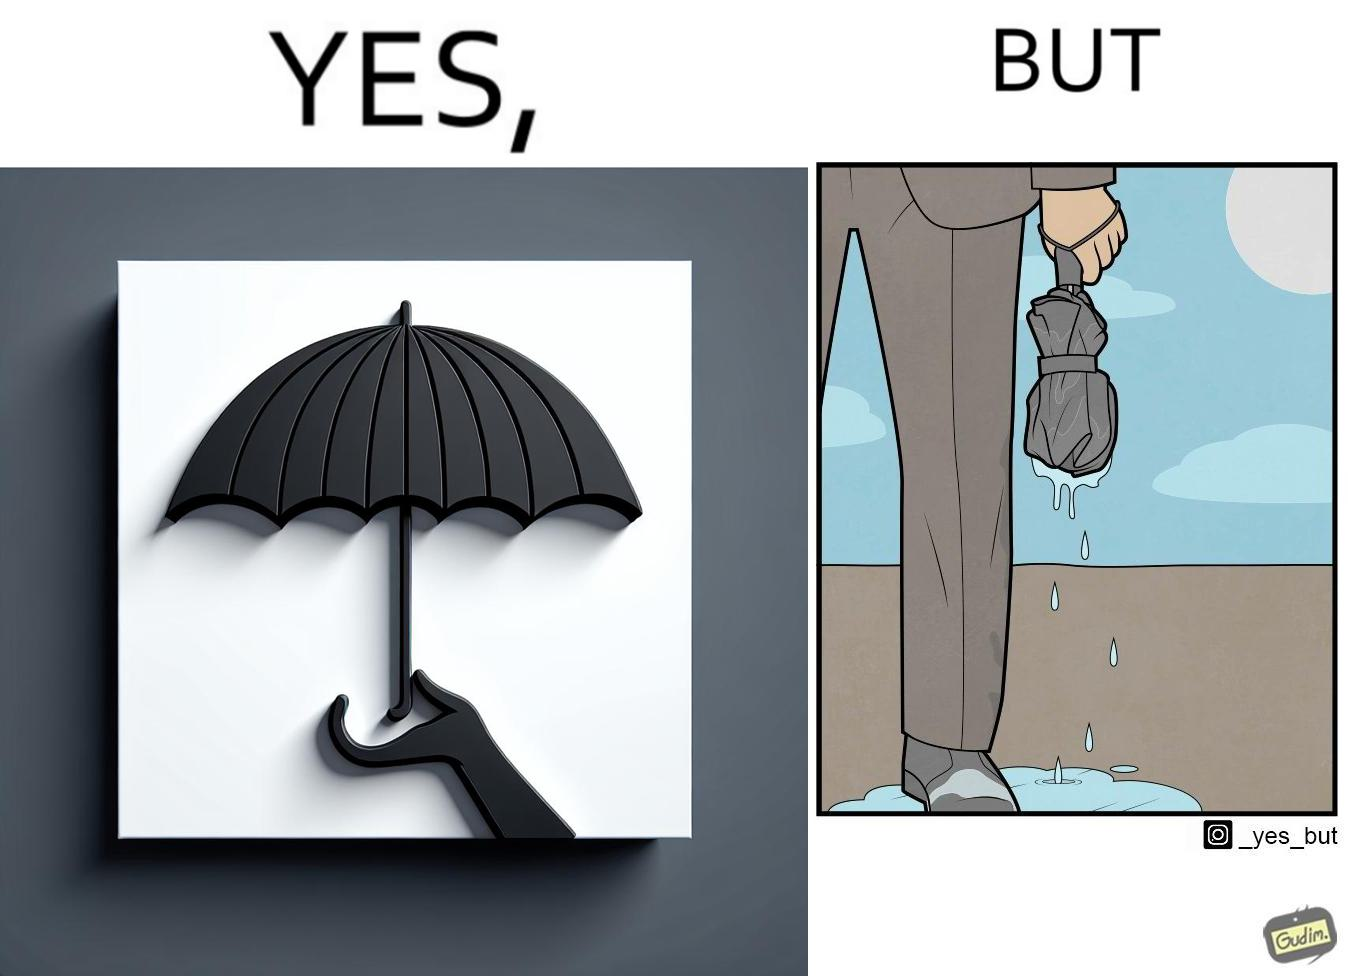Describe what you see in the left and right parts of this image. In the left part of the image: The image shows a hand holding an open black umbrella during rain. The open umbrella is stopping the raindrops to fall below it. In the right part of the image: The image shows water dripping from a wet, folded umberlla in a man's hand. The water is all over the man's shoe and the floor around it. 